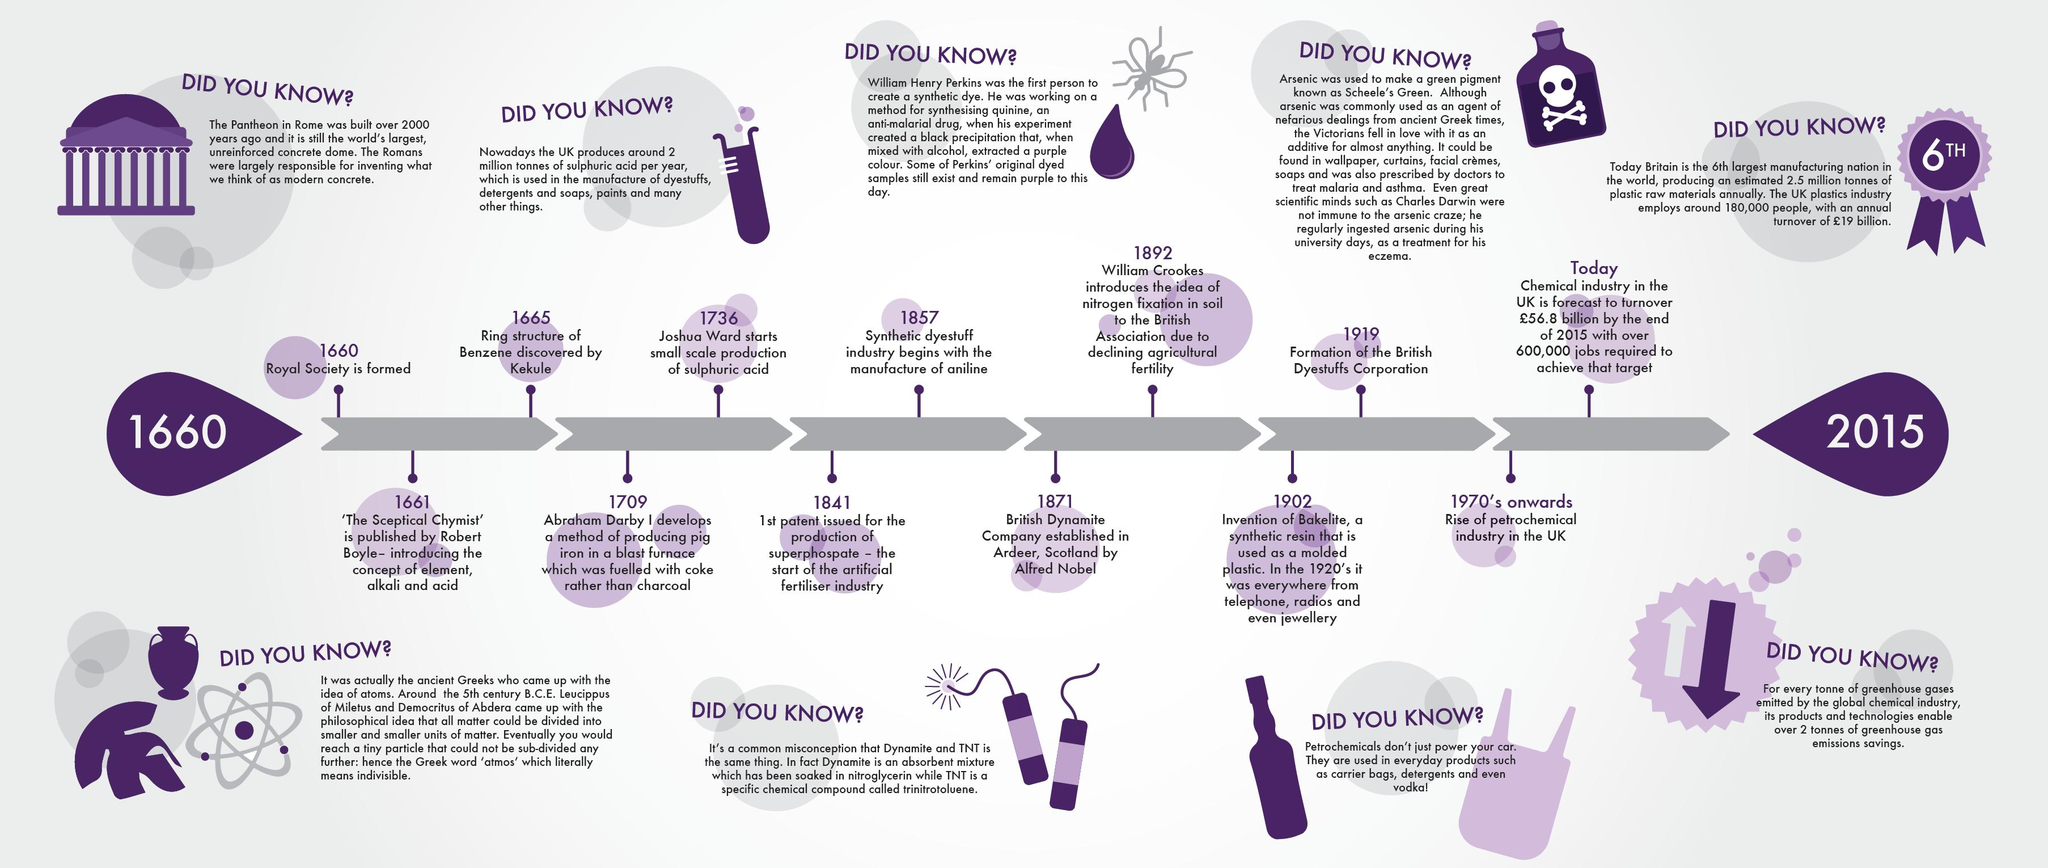Identify some key points in this picture. Alfred Nobel established the British Dynamite Company in Scotland. The British Dyestuffs Corporation was formed in 1919. The rise of the petrochemical industry in the UK began in the 1970's and continues to this day. The book "The Sceptical Chymist" by Robert Boyle was published in 1661. The ring structure of benzene was first discovered by Kekule in 1865. 